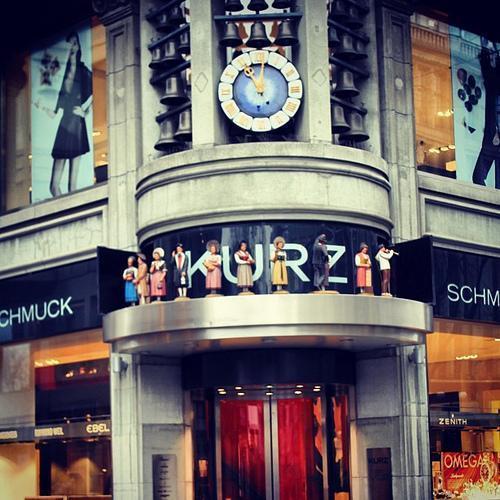How many clocks are visible?
Give a very brief answer. 1. 